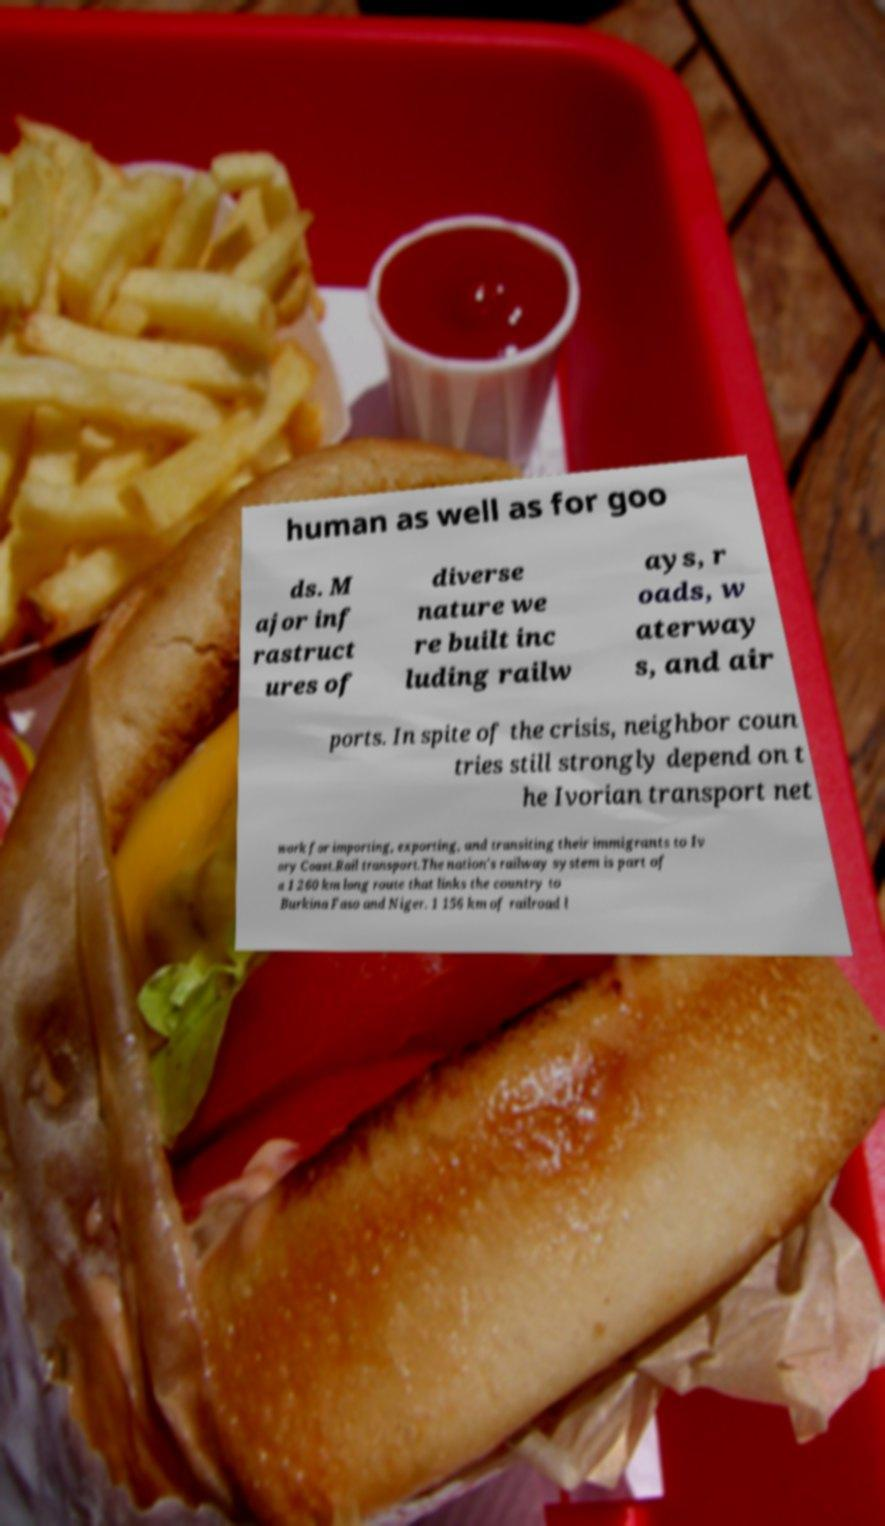Could you assist in decoding the text presented in this image and type it out clearly? human as well as for goo ds. M ajor inf rastruct ures of diverse nature we re built inc luding railw ays, r oads, w aterway s, and air ports. In spite of the crisis, neighbor coun tries still strongly depend on t he Ivorian transport net work for importing, exporting, and transiting their immigrants to Iv ory Coast.Rail transport.The nation's railway system is part of a 1 260 km long route that links the country to Burkina Faso and Niger. 1 156 km of railroad l 